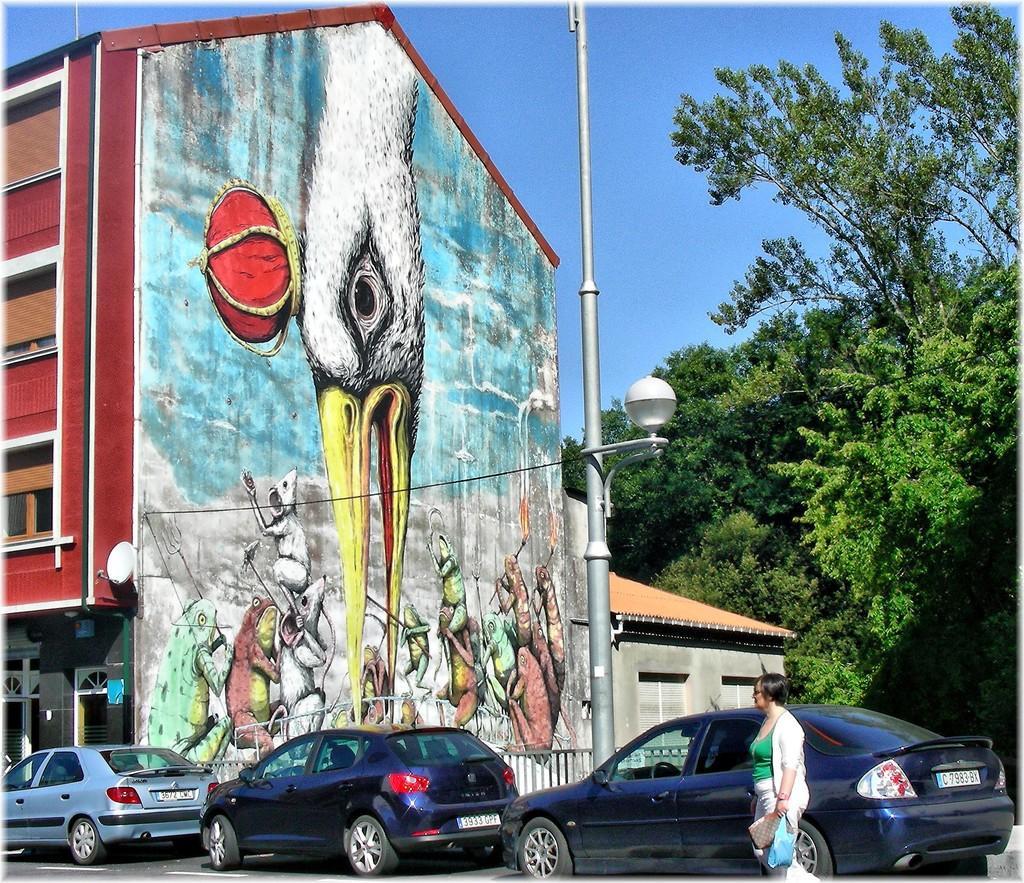Can you describe this image briefly? In this picture we can observe a painting on the wall of the building. We can observe a bird on the wall. There are some animals painted on this wall. The building is in maroon color. We can observe some cars on the road. There is a pole. On the right side we can observe trees. In the background there is a sky. 